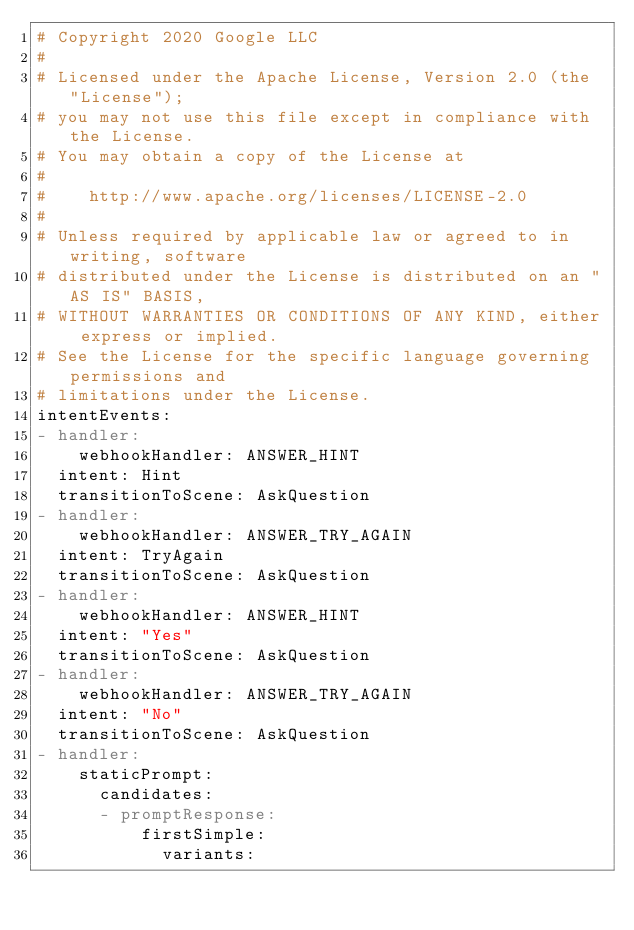<code> <loc_0><loc_0><loc_500><loc_500><_YAML_># Copyright 2020 Google LLC
#
# Licensed under the Apache License, Version 2.0 (the "License");
# you may not use this file except in compliance with the License.
# You may obtain a copy of the License at
#
#    http://www.apache.org/licenses/LICENSE-2.0
#
# Unless required by applicable law or agreed to in writing, software
# distributed under the License is distributed on an "AS IS" BASIS,
# WITHOUT WARRANTIES OR CONDITIONS OF ANY KIND, either express or implied.
# See the License for the specific language governing permissions and
# limitations under the License.
intentEvents:
- handler:
    webhookHandler: ANSWER_HINT
  intent: Hint
  transitionToScene: AskQuestion
- handler:
    webhookHandler: ANSWER_TRY_AGAIN
  intent: TryAgain
  transitionToScene: AskQuestion
- handler:
    webhookHandler: ANSWER_HINT
  intent: "Yes"
  transitionToScene: AskQuestion
- handler:
    webhookHandler: ANSWER_TRY_AGAIN
  intent: "No"
  transitionToScene: AskQuestion
- handler:
    staticPrompt:
      candidates:
      - promptResponse:
          firstSimple:
            variants:</code> 